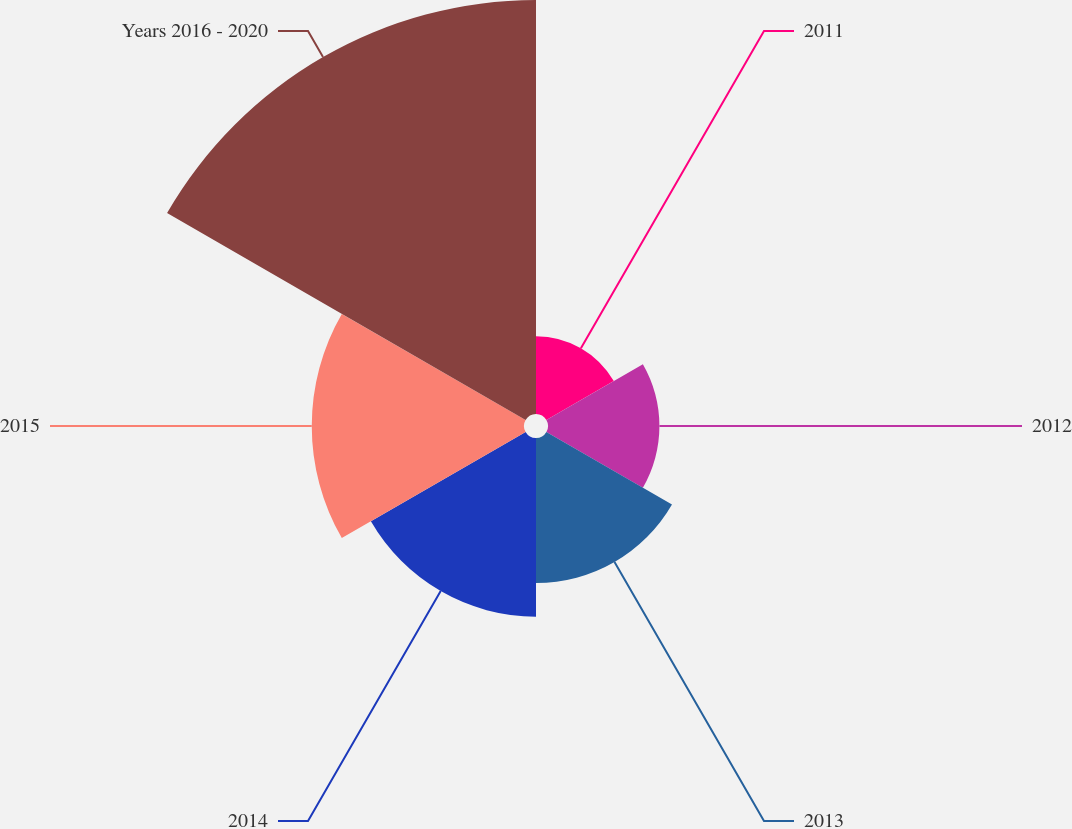<chart> <loc_0><loc_0><loc_500><loc_500><pie_chart><fcel>2011<fcel>2012<fcel>2013<fcel>2014<fcel>2015<fcel>Years 2016 - 2020<nl><fcel>6.83%<fcel>9.78%<fcel>12.73%<fcel>15.68%<fcel>18.63%<fcel>36.34%<nl></chart> 